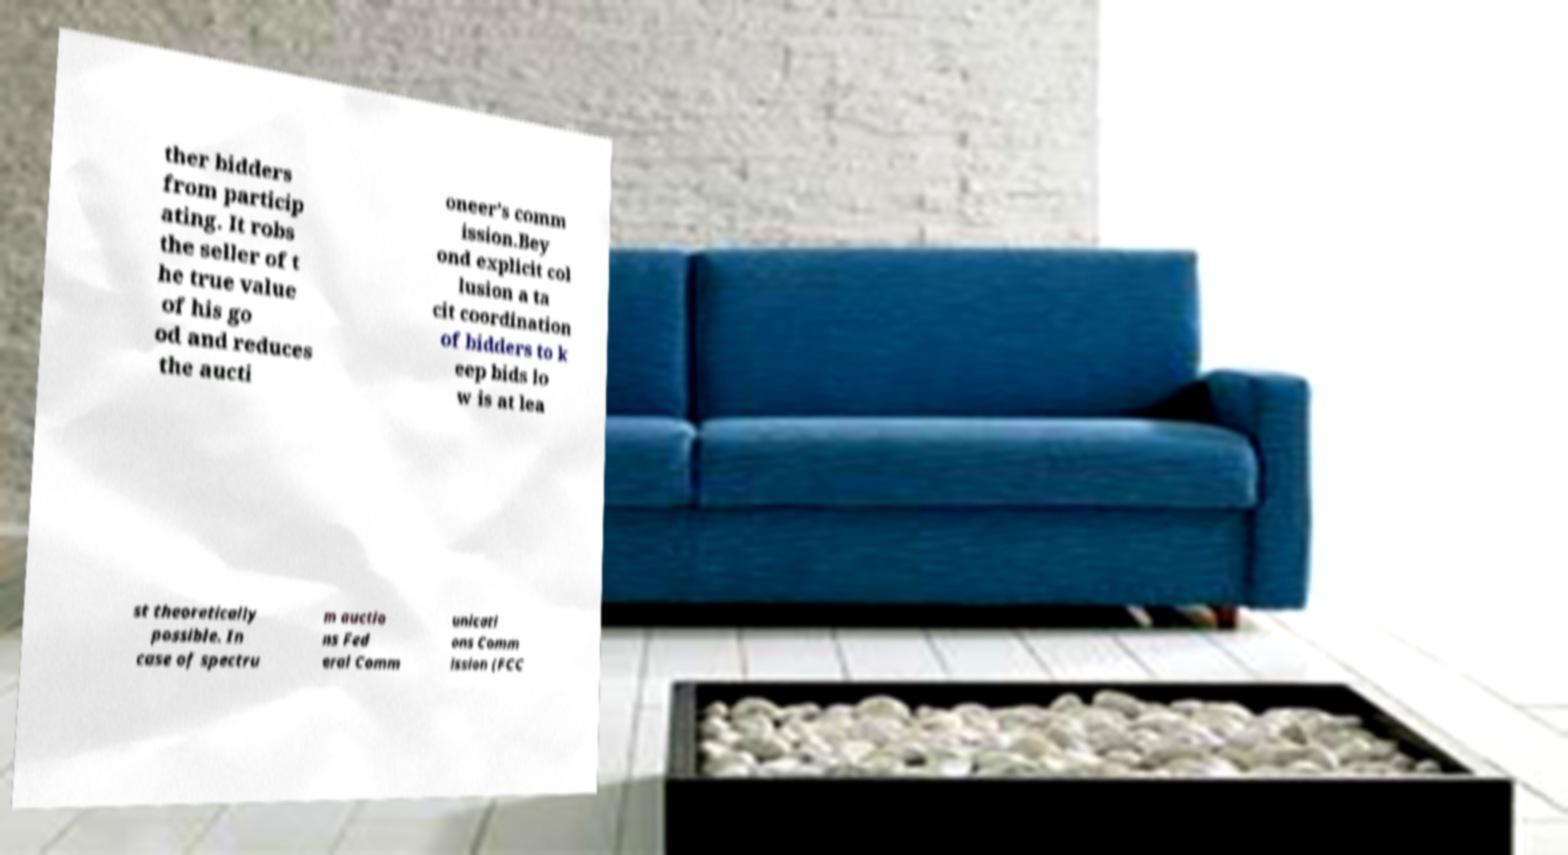What messages or text are displayed in this image? I need them in a readable, typed format. ther bidders from particip ating. It robs the seller of t he true value of his go od and reduces the aucti oneer’s comm ission.Bey ond explicit col lusion a ta cit coordination of bidders to k eep bids lo w is at lea st theoretically possible. In case of spectru m auctio ns Fed eral Comm unicati ons Comm ission (FCC 